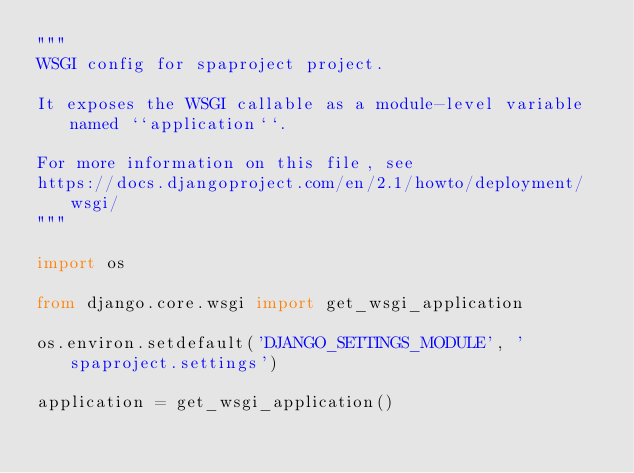Convert code to text. <code><loc_0><loc_0><loc_500><loc_500><_Python_>"""
WSGI config for spaproject project.

It exposes the WSGI callable as a module-level variable named ``application``.

For more information on this file, see
https://docs.djangoproject.com/en/2.1/howto/deployment/wsgi/
"""

import os

from django.core.wsgi import get_wsgi_application

os.environ.setdefault('DJANGO_SETTINGS_MODULE', 'spaproject.settings')

application = get_wsgi_application()
</code> 